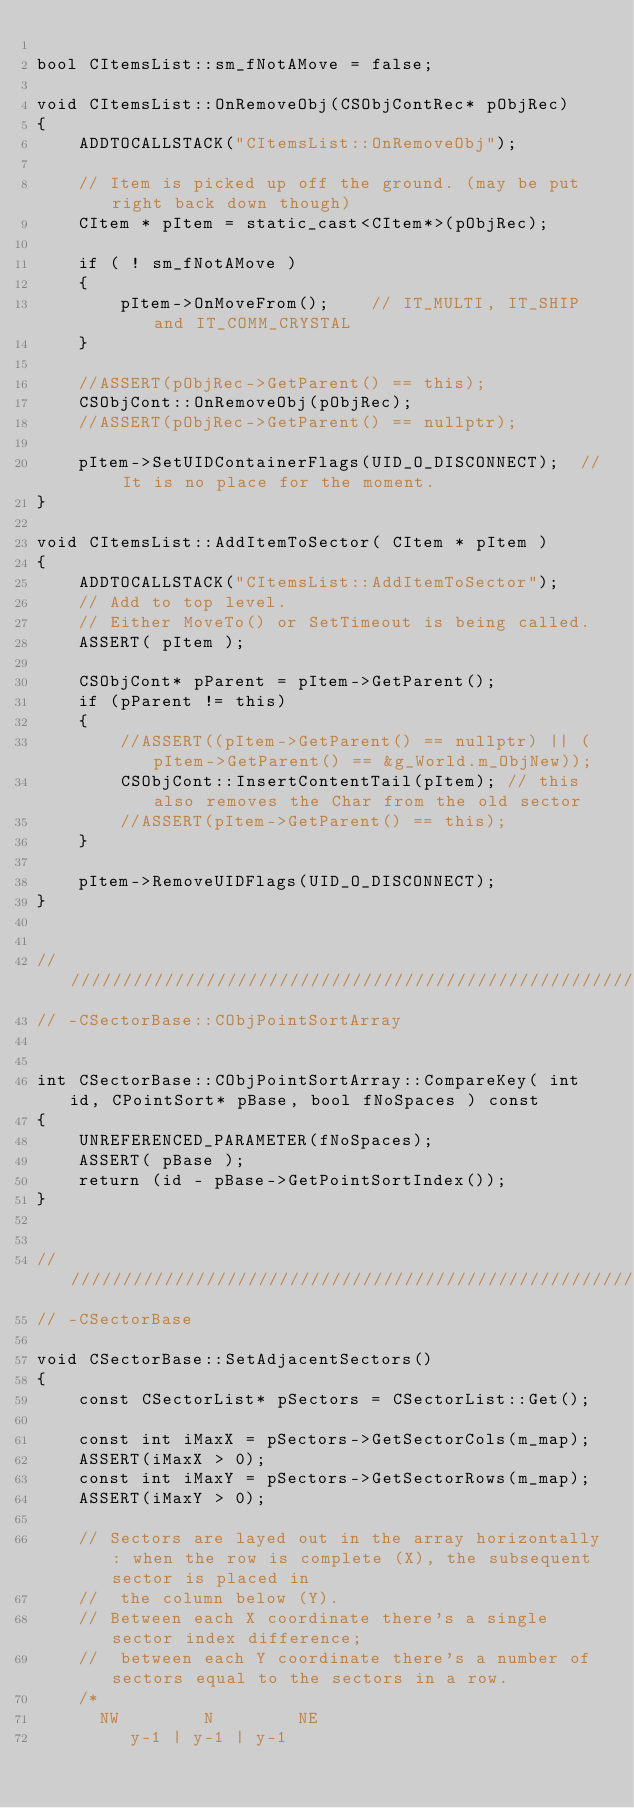Convert code to text. <code><loc_0><loc_0><loc_500><loc_500><_C++_>
bool CItemsList::sm_fNotAMove = false;

void CItemsList::OnRemoveObj(CSObjContRec* pObjRec)
{
	ADDTOCALLSTACK("CItemsList::OnRemoveObj");

	// Item is picked up off the ground. (may be put right back down though)
	CItem * pItem = static_cast<CItem*>(pObjRec);

	if ( ! sm_fNotAMove )
	{
		pItem->OnMoveFrom();	// IT_MULTI, IT_SHIP and IT_COMM_CRYSTAL
	}

	//ASSERT(pObjRec->GetParent() == this);
	CSObjCont::OnRemoveObj(pObjRec);
	//ASSERT(pObjRec->GetParent() == nullptr);

	pItem->SetUIDContainerFlags(UID_O_DISCONNECT);	// It is no place for the moment.
}

void CItemsList::AddItemToSector( CItem * pItem )
{
	ADDTOCALLSTACK("CItemsList::AddItemToSector");
	// Add to top level.
	// Either MoveTo() or SetTimeout is being called.
	ASSERT( pItem );

	CSObjCont* pParent = pItem->GetParent();
	if (pParent != this)
	{
		//ASSERT((pItem->GetParent() == nullptr) || (pItem->GetParent() == &g_World.m_ObjNew));
		CSObjCont::InsertContentTail(pItem); // this also removes the Char from the old sector
		//ASSERT(pItem->GetParent() == this);
	}

    pItem->RemoveUIDFlags(UID_O_DISCONNECT);
}


//////////////////////////////////////////////////////////////////
// -CSectorBase::CObjPointSortArray


int CSectorBase::CObjPointSortArray::CompareKey( int id, CPointSort* pBase, bool fNoSpaces ) const
{
    UNREFERENCED_PARAMETER(fNoSpaces);
    ASSERT( pBase );
    return (id - pBase->GetPointSortIndex());
}


//////////////////////////////////////////////////////////////////
// -CSectorBase

void CSectorBase::SetAdjacentSectors()
{
	const CSectorList* pSectors = CSectorList::Get();

    const int iMaxX = pSectors->GetSectorCols(m_map);
    ASSERT(iMaxX > 0);
    const int iMaxY = pSectors->GetSectorRows(m_map);
    ASSERT(iMaxY > 0);

    // Sectors are layed out in the array horizontally: when the row is complete (X), the subsequent sector is placed in
    //  the column below (Y).
    // Between each X coordinate there's a single sector index difference;
    //  between each Y coordinate there's a number of sectors equal to the sectors in a row.
    /*
      NW        N        NE
         y-1 | y-1 | y-1</code> 